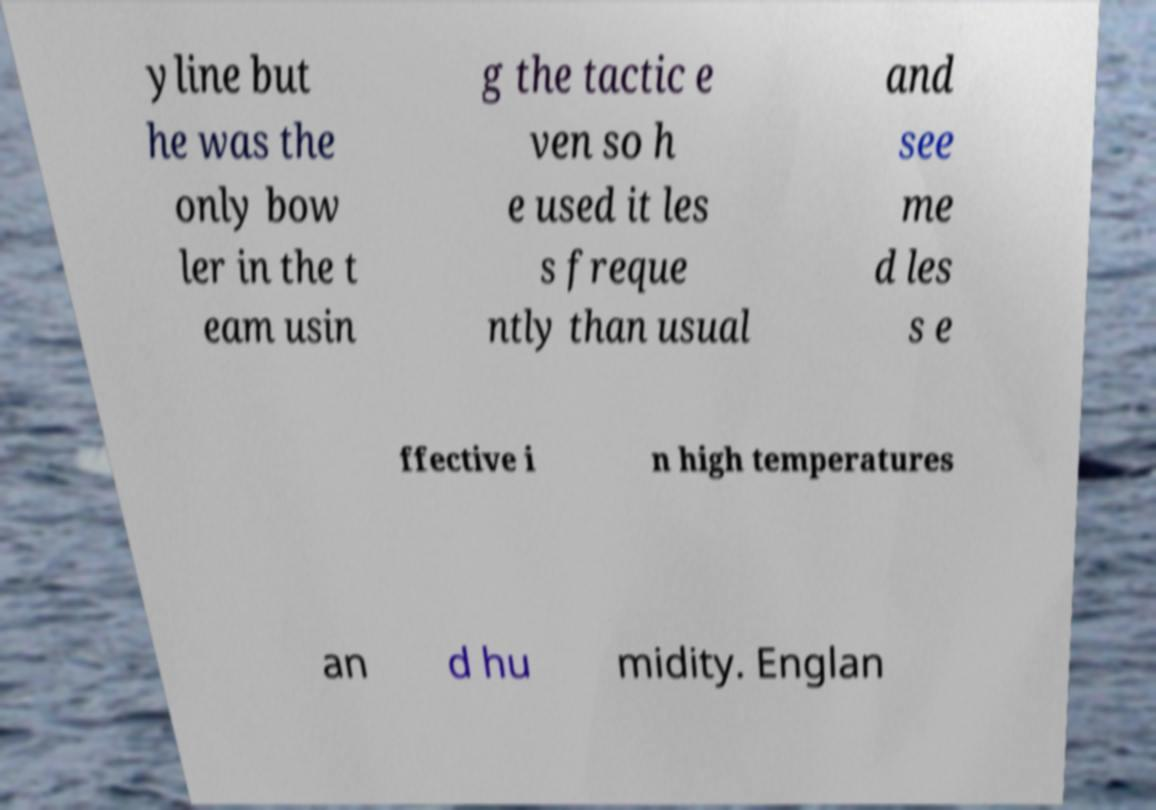Could you extract and type out the text from this image? yline but he was the only bow ler in the t eam usin g the tactic e ven so h e used it les s freque ntly than usual and see me d les s e ffective i n high temperatures an d hu midity. Englan 